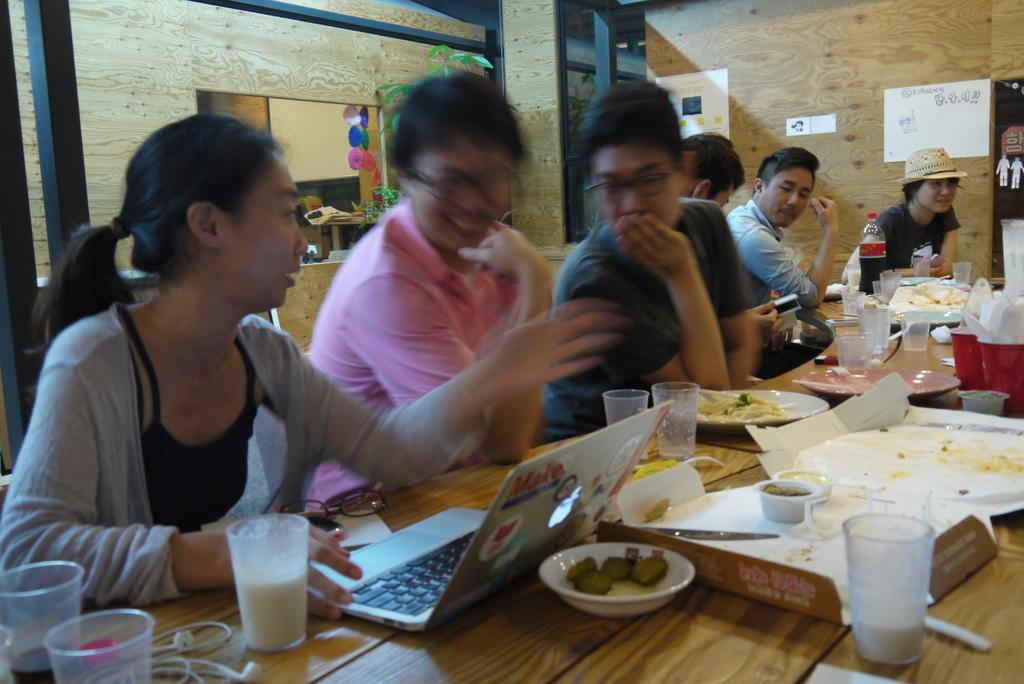What are the people in the image doing? The group of people is sitting on chairs. What is in front of the chairs? There is a table in front of the chairs. What electronic device is on the table? A laptop is present on the table. What else can be seen on the table besides the laptop? There are objects on the table. What is visible behind the people and table? There is a wall visible in the image. What type of mine can be seen in the image? There is no mine present in the image; it features a group of people sitting on chairs with a table and a laptop. What color is the glove on the table? There is no glove present on the table in the image. 